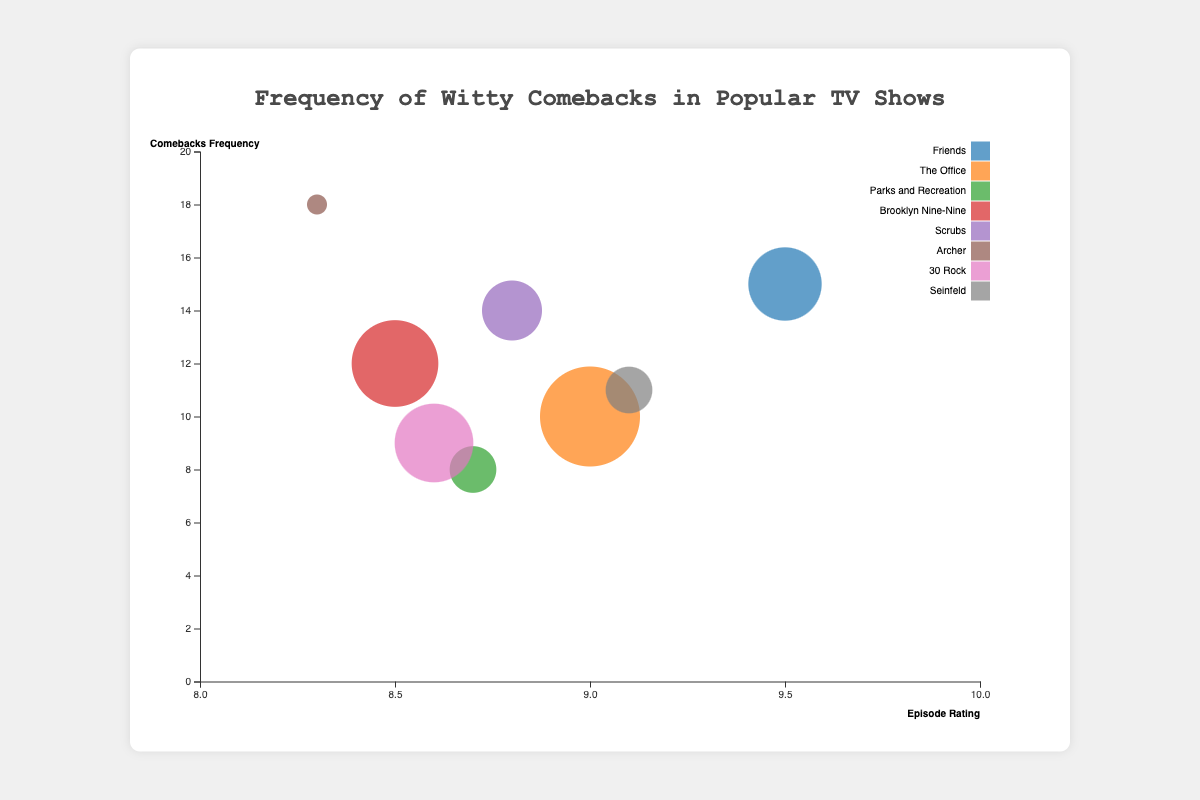How many data points are represented in the bubble chart? The chart includes one bubble per row in the dataset. There are 8 rows, so there are 8 bubbles.
Answer: 8 Which character has the highest frequency of witty comebacks? The y-axis represents comebacks frequency. The highest point on the y-axis corresponds to Sterling Archer with 18 comebacks.
Answer: Sterling Archer What is the show with the lowest character development value, and what is that value? The bubble size represents character development. The smallest bubble indicates the lowest value. Sterling Archer from "Archer" has the smallest bubble with a character development value of 0.6.
Answer: Archer, 0.6 Which character has a higher episode rating, Michael Scott or George Costanza? The x-axis represents episode ratings. By comparing their positions on the x-axis, George Costanza has a higher rating (9.1) than Michael Scott (9.0).
Answer: George Costanza What is the average episode rating of characters with a frequency of witty comebacks greater than 10? Identify characters with more than 10 comebacks: Chandler Bing, Jake Peralta, Dr. Perry Cox, and Sterling Archer. Their episode ratings are 9.5, 8.5, 8.8, and 8.3. The average is (9.5 + 8.5 + 8.8 + 8.3) / 4 = 8.775.
Answer: 8.775 Which character has the most balanced metrics in terms of episode rating near 9.0 and comebacks frequency around 10? Check bubbles closest to both criteria. Michael Scott from "The Office" fits both criteria closely with an episode rating of 9.0 and a comebacks frequency of 10.
Answer: Michael Scott Is there any show where the character's comebacks frequency is less than 10 but has character development higher than 0.7? Check for comebacks frequency < 10 and development > 0.7. "Parks and Recreation" (Ron Swanson: 8, 0.7) and "30 Rock" (Liz Lemon: 9, 0.82).
Answer: Parks and Recreation, 30 Rock What is the relationship between episode rating and comebacks frequency for Jake Peralta? Locate Jake Peralta's bubble and check the coordinates. Jake Peralta has an episode rating of 8.5 and a comebacks frequency of 12, indicating a moderate relationship between the two.
Answer: 8.5 episode rating, 12 comebacks frequency 